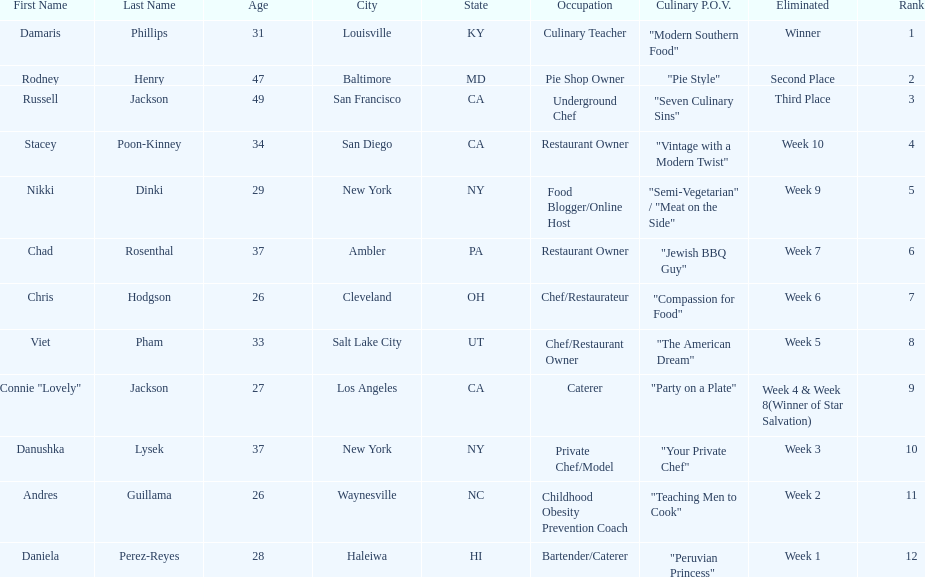Which contestant is the same age as chris hodgson? Andres Guillama. 